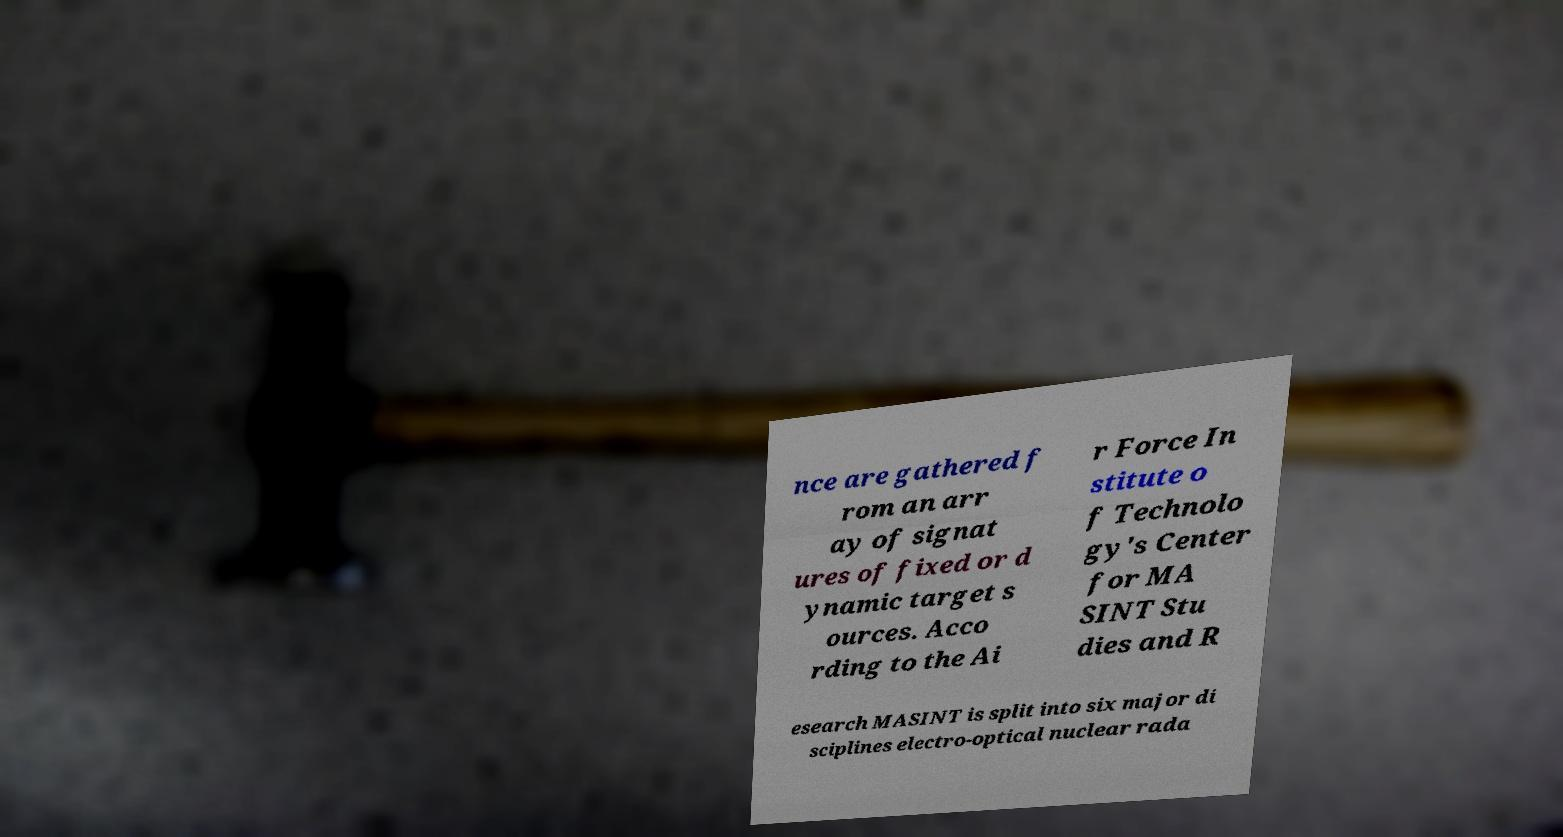There's text embedded in this image that I need extracted. Can you transcribe it verbatim? nce are gathered f rom an arr ay of signat ures of fixed or d ynamic target s ources. Acco rding to the Ai r Force In stitute o f Technolo gy's Center for MA SINT Stu dies and R esearch MASINT is split into six major di sciplines electro-optical nuclear rada 